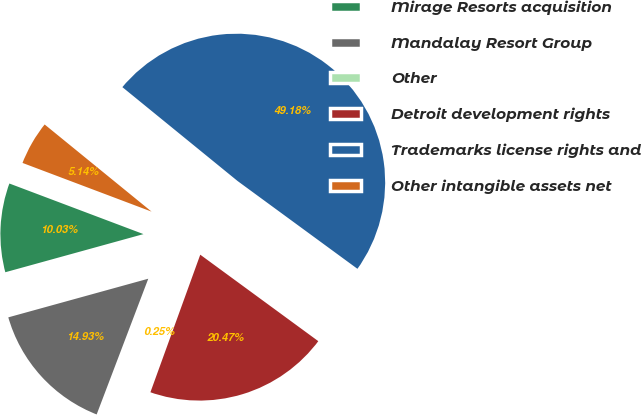Convert chart to OTSL. <chart><loc_0><loc_0><loc_500><loc_500><pie_chart><fcel>Mirage Resorts acquisition<fcel>Mandalay Resort Group<fcel>Other<fcel>Detroit development rights<fcel>Trademarks license rights and<fcel>Other intangible assets net<nl><fcel>10.03%<fcel>14.93%<fcel>0.25%<fcel>20.47%<fcel>49.18%<fcel>5.14%<nl></chart> 